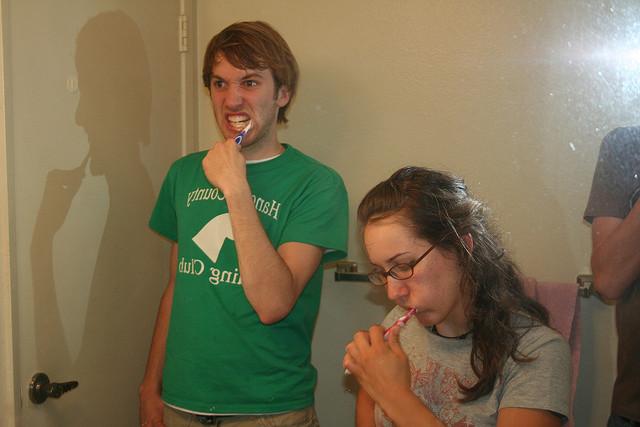Is there a celebration going on?
Quick response, please. No. Does the lady wearing makeup?
Answer briefly. No. What does the standing man have in his mouth?
Be succinct. Toothbrush. How many people are visible?
Write a very short answer. 3. What is this man eating?
Answer briefly. Toothpaste. Are they sitting on a couch?
Answer briefly. No. What is the main color of the girl's shirt?
Keep it brief. Gray. Is the door open?
Concise answer only. No. Are these people at home?
Concise answer only. Yes. What color of shirt is he wearing?
Concise answer only. Green. What is the man playing?
Concise answer only. Brushing teeth. Does the woman look like she is having fun?
Give a very brief answer. No. What is the girl pulling on?
Keep it brief. Toothbrush. Is this where people usually brush their teeth?
Short answer required. Yes. What are the people brushing?
Short answer required. Teeth. Is the girl wearing a necklace?
Be succinct. No. Where is the boy?
Keep it brief. Bathroom. What motion does the man on the left appear to be doing?
Keep it brief. Brushing. Is the woman wearing glasses?
Answer briefly. Yes. What is the man holding?
Keep it brief. Toothbrush. What is the pattern of the man's shirt?
Keep it brief. Solid. What is the man wearing on the face?
Concise answer only. Nothing. What color is the toothbrush?
Keep it brief. Red and blue. What game are these men playing?
Quick response, please. Brushing teeth. What color is her top?
Write a very short answer. Gray. Are any of the women wearing suits?
Quick response, please. No. What does this guy have in his hands?
Give a very brief answer. Toothbrush. Do you think the lady is enjoying herself?
Short answer required. No. Does he have long hair?
Quick response, please. No. What color is the person's hair?
Write a very short answer. Brown. Where do you see a tattoo?
Quick response, please. Nowhere. What hand is holding the brush?
Quick response, please. Left. What hand does the boy use?
Be succinct. Left. Are these two a couple?
Give a very brief answer. No. What are the children doing?
Quick response, please. Brushing teeth. What color is the brush?
Concise answer only. Pink. What is the girl holding in her left hand?
Write a very short answer. Toothbrush. Are these people celebrating something?
Quick response, please. No. What is the gentlemen messing with?
Write a very short answer. Toothbrush. Are they watching something?
Short answer required. No. Does that look like a Transformers insignia on her hand to you?
Keep it brief. No. Is the woman on the right happy?
Short answer required. No. Are they playing a game?
Short answer required. No. What is she holding?
Write a very short answer. Toothbrush. Is the man young?
Be succinct. Yes. What is the lady holding?
Give a very brief answer. Toothbrush. Is the woman playing a WII game?
Concise answer only. No. How many people are in this photo?
Keep it brief. 3. Does the girl appear surprised?
Be succinct. No. Is this man brushing his teeth?
Concise answer only. Yes. Are they happy?
Concise answer only. No. Does this man wear glasses?
Concise answer only. No. What are the women holding?
Give a very brief answer. Toothbrush. What is the man on the left looking at?
Keep it brief. Mirror. What color is the woman's hair?
Write a very short answer. Brown. Is the lady amused?
Be succinct. No. What room is she in?
Quick response, please. Bathroom. How many rings does she have on her fingers?
Concise answer only. 0. Is this bathroom finished?
Concise answer only. Yes. Is she laying on her belly?
Give a very brief answer. No. What color is the shirt?
Answer briefly. Green. Are they both smiling?
Answer briefly. No. What color is everyone wearing?
Concise answer only. Green and gray. What's the couple doing?
Keep it brief. Brushing teeth. Is she wearing a tie?
Be succinct. No. Is the woman happy?
Concise answer only. No. What is this front woman's favorite team?
Keep it brief. Can't tell. What color is the girl's shirt?
Keep it brief. Gray. Is it someone's birthday?
Short answer required. No. Does the woman color her hair?
Keep it brief. No. What is the man doing?
Concise answer only. Brushing teeth. Are the people in the photo having a good time?
Concise answer only. No. How many of the people have long hair?
Give a very brief answer. 1. Are they enjoying themselves?
Concise answer only. No. How old is the man?
Write a very short answer. 18. What is on in the background?
Give a very brief answer. Wall. What is the woman holding on her cheek?
Write a very short answer. Toothbrush. What's in the guy's neck?
Concise answer only. Nothing. Are the people smiling?
Write a very short answer. No. Why is the man bearing this teeth?
Short answer required. Brushing. Which girl is wearing glasses?
Write a very short answer. Right. What is the girl eating in the picture?
Write a very short answer. Toothbrush. 